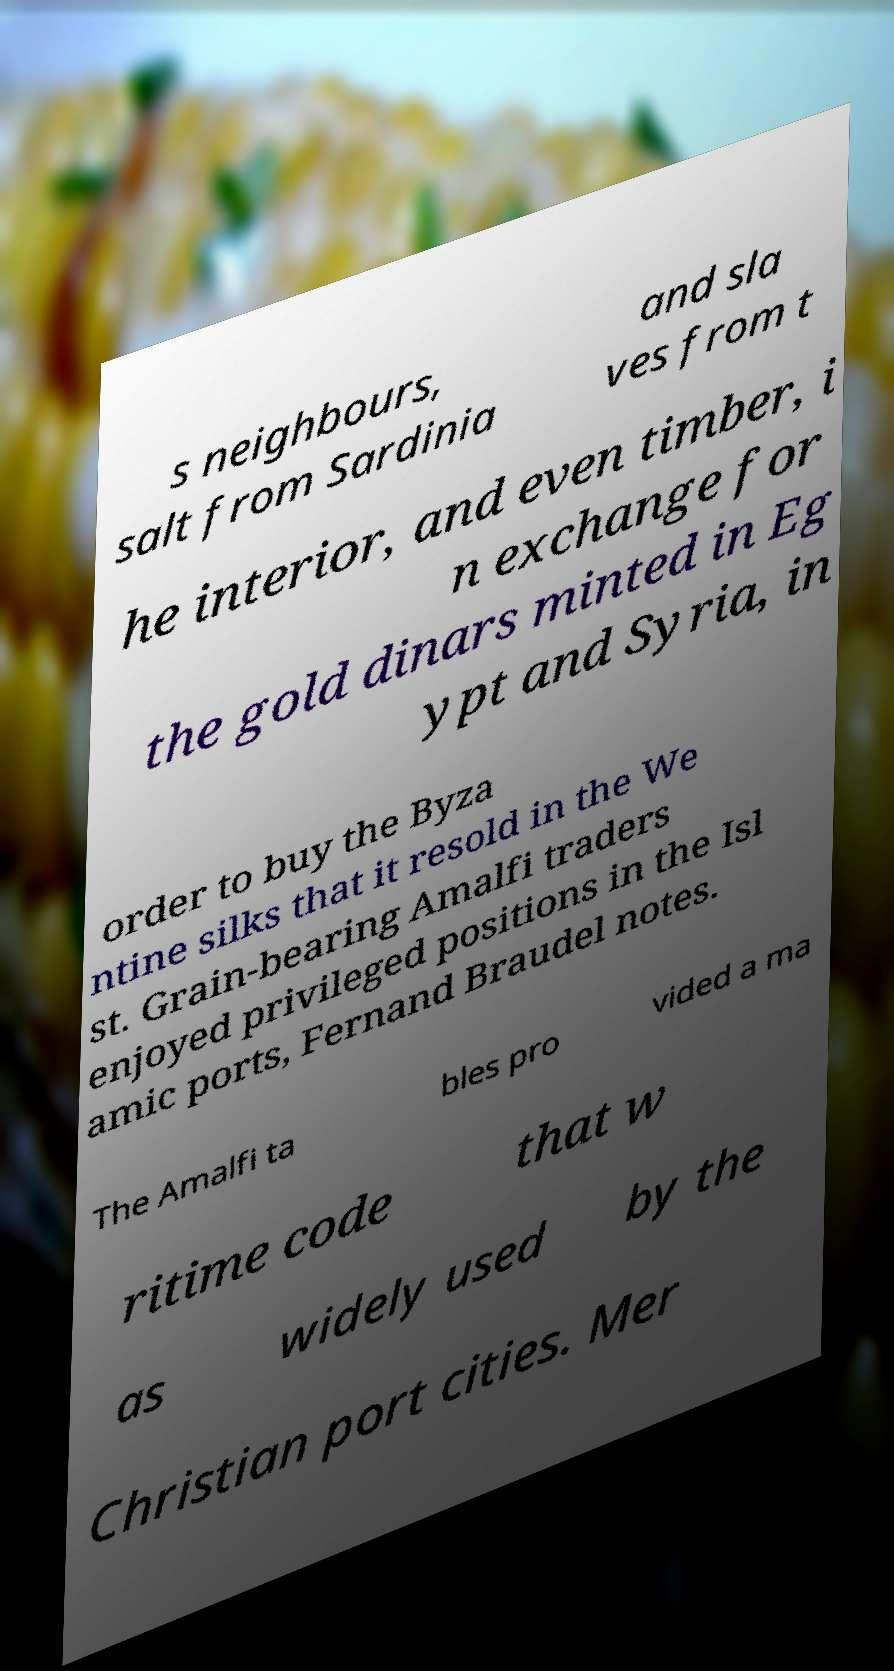There's text embedded in this image that I need extracted. Can you transcribe it verbatim? s neighbours, salt from Sardinia and sla ves from t he interior, and even timber, i n exchange for the gold dinars minted in Eg ypt and Syria, in order to buy the Byza ntine silks that it resold in the We st. Grain-bearing Amalfi traders enjoyed privileged positions in the Isl amic ports, Fernand Braudel notes. The Amalfi ta bles pro vided a ma ritime code that w as widely used by the Christian port cities. Mer 